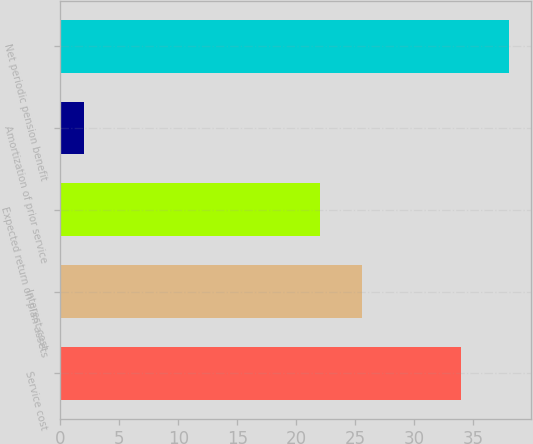<chart> <loc_0><loc_0><loc_500><loc_500><bar_chart><fcel>Service cost<fcel>Interest cost<fcel>Expected return on plan assets<fcel>Amortization of prior service<fcel>Net periodic pension benefit<nl><fcel>34<fcel>25.6<fcel>22<fcel>2<fcel>38<nl></chart> 